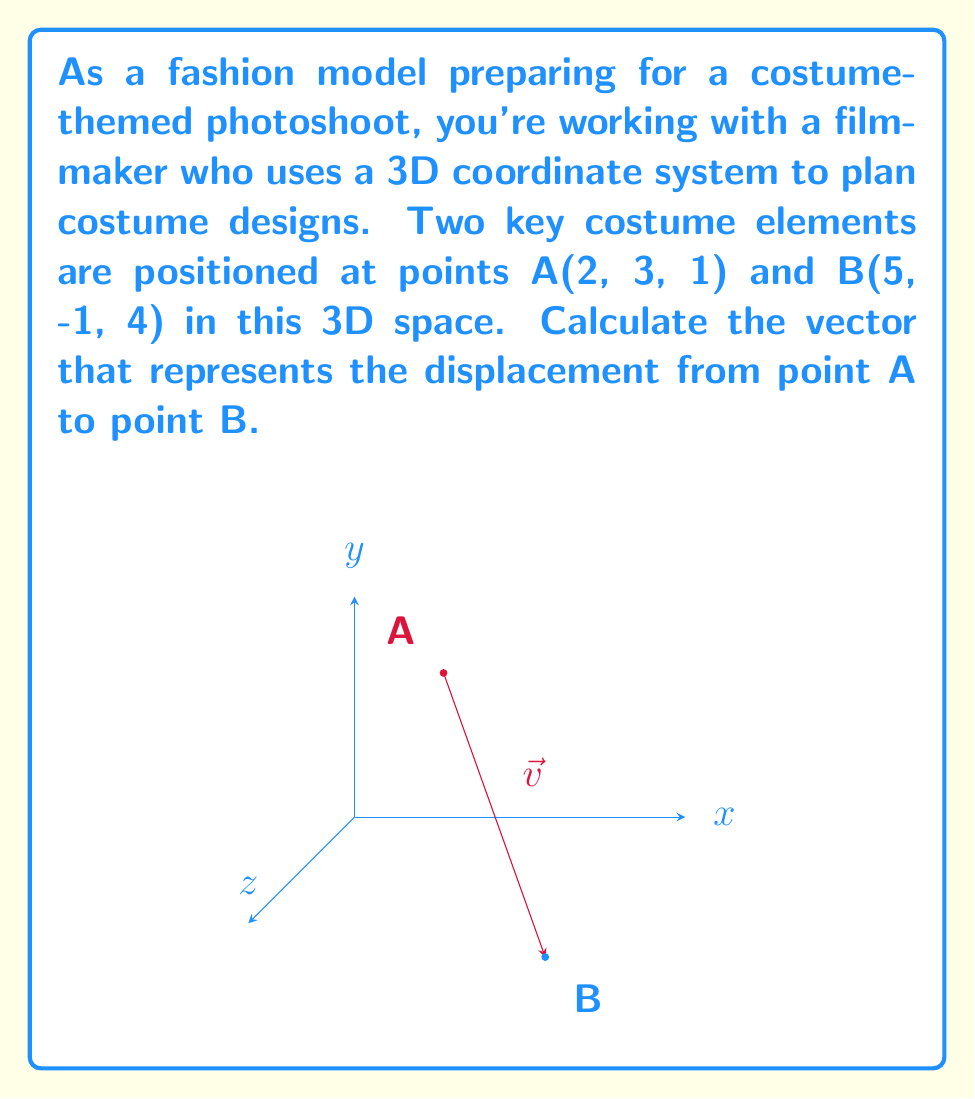Could you help me with this problem? Let's approach this step-by-step:

1) The vector from point A to point B, let's call it $\vec{v}$, is calculated by subtracting the coordinates of point A from point B.

2) The formula for this vector is:
   $$\vec{v} = \vec{B} - \vec{A}$$

3) We know that:
   A(2, 3, 1) and B(5, -1, 4)

4) Let's substitute these into our formula:
   $$\vec{v} = (5, -1, 4) - (2, 3, 1)$$

5) Now, we perform the subtraction for each component:
   $$\vec{v} = (5-2, -1-3, 4-1)$$

6) Simplifying:
   $$\vec{v} = (3, -4, 3)$$

This vector $(3, -4, 3)$ represents the displacement from point A to point B in the 3D costume design space.
Answer: $(3, -4, 3)$ 